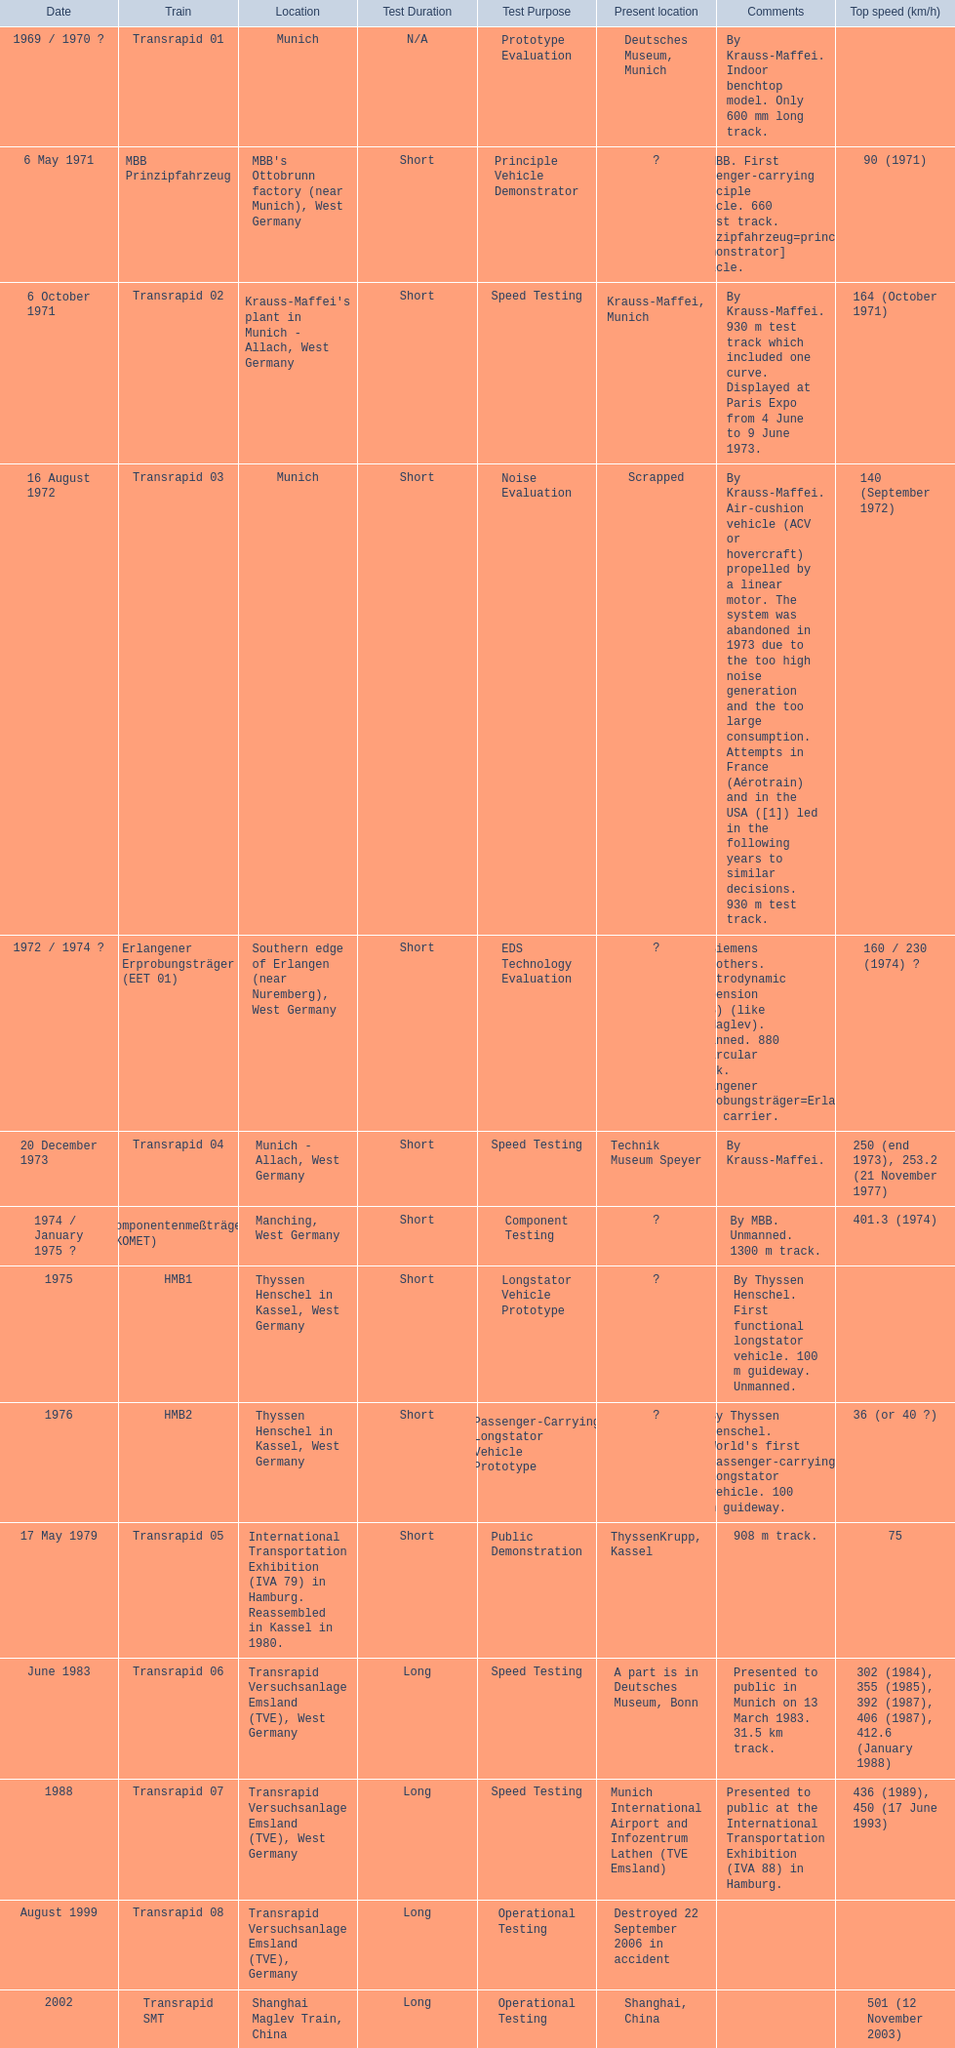What are all trains? Transrapid 01, MBB Prinzipfahrzeug, Transrapid 02, Transrapid 03, Erlangener Erprobungsträger (EET 01), Transrapid 04, Komponentenmeßträger (KOMET), HMB1, HMB2, Transrapid 05, Transrapid 06, Transrapid 07, Transrapid 08, Transrapid SMT, Transrapid 09. Which of all location of trains are known? Deutsches Museum, Munich, Krauss-Maffei, Munich, Scrapped, Technik Museum Speyer, ThyssenKrupp, Kassel, A part is in Deutsches Museum, Bonn, Munich International Airport and Infozentrum Lathen (TVE Emsland), Destroyed 22 September 2006 in accident, Shanghai, China. Which of those trains were scrapped? Transrapid 03. 